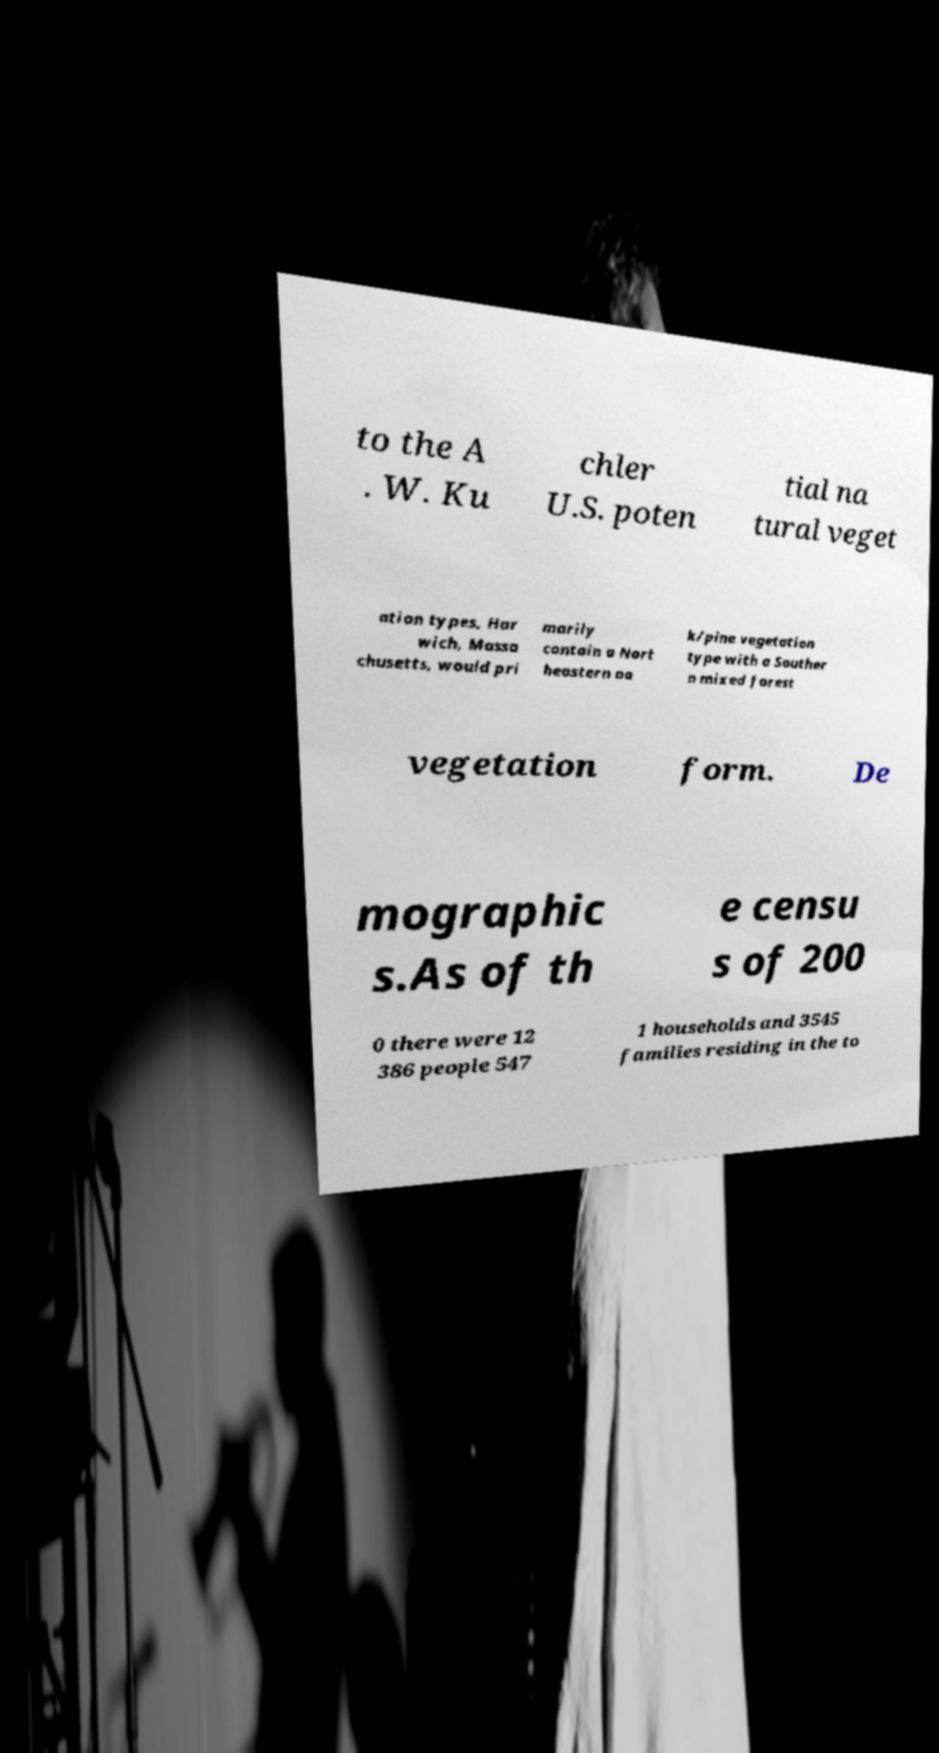Can you read and provide the text displayed in the image?This photo seems to have some interesting text. Can you extract and type it out for me? to the A . W. Ku chler U.S. poten tial na tural veget ation types, Har wich, Massa chusetts, would pri marily contain a Nort heastern oa k/pine vegetation type with a Souther n mixed forest vegetation form. De mographic s.As of th e censu s of 200 0 there were 12 386 people 547 1 households and 3545 families residing in the to 